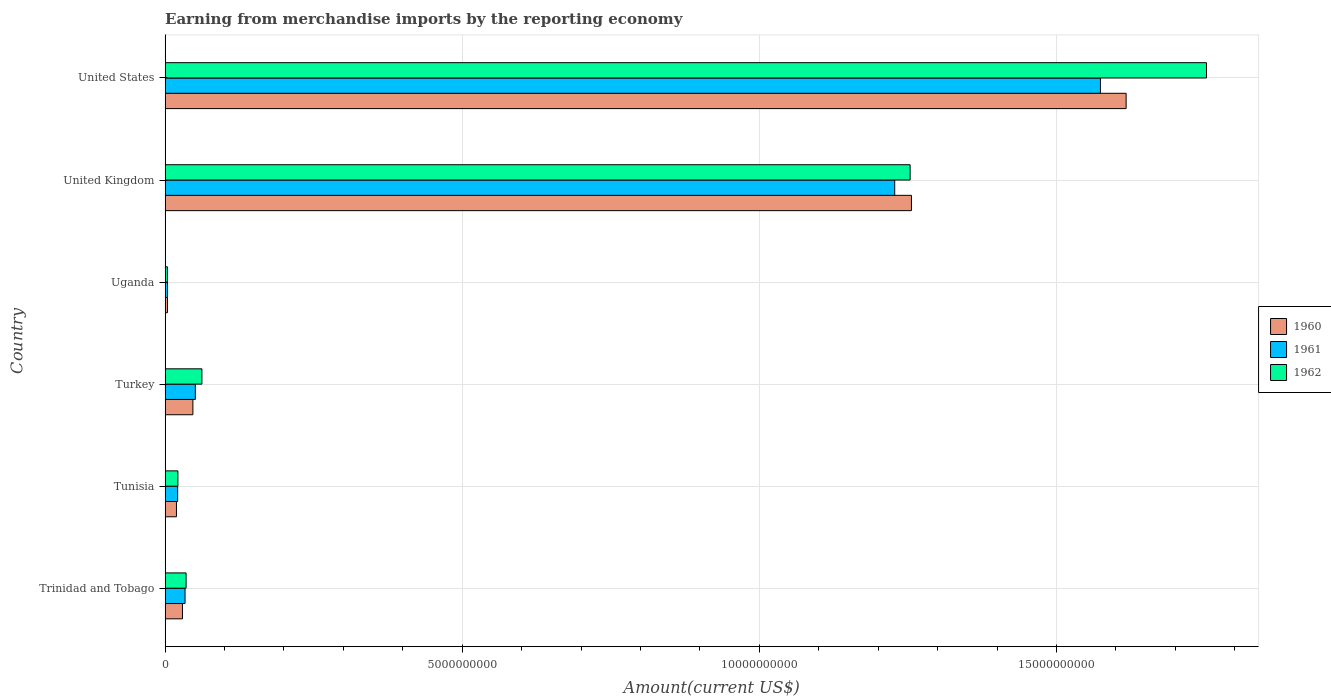Are the number of bars per tick equal to the number of legend labels?
Offer a very short reply. Yes. Are the number of bars on each tick of the Y-axis equal?
Ensure brevity in your answer.  Yes. How many bars are there on the 6th tick from the bottom?
Your answer should be very brief. 3. What is the label of the 2nd group of bars from the top?
Offer a terse response. United Kingdom. What is the amount earned from merchandise imports in 1960 in United Kingdom?
Provide a short and direct response. 1.26e+1. Across all countries, what is the maximum amount earned from merchandise imports in 1960?
Make the answer very short. 1.62e+1. Across all countries, what is the minimum amount earned from merchandise imports in 1960?
Your answer should be compact. 4.01e+07. In which country was the amount earned from merchandise imports in 1960 minimum?
Your answer should be very brief. Uganda. What is the total amount earned from merchandise imports in 1960 in the graph?
Your answer should be very brief. 2.97e+1. What is the difference between the amount earned from merchandise imports in 1960 in Tunisia and that in United States?
Provide a short and direct response. -1.60e+1. What is the difference between the amount earned from merchandise imports in 1960 in Uganda and the amount earned from merchandise imports in 1961 in United States?
Your answer should be very brief. -1.57e+1. What is the average amount earned from merchandise imports in 1961 per country?
Offer a terse response. 4.85e+09. What is the difference between the amount earned from merchandise imports in 1961 and amount earned from merchandise imports in 1960 in Turkey?
Make the answer very short. 4.11e+07. In how many countries, is the amount earned from merchandise imports in 1962 greater than 6000000000 US$?
Offer a terse response. 2. What is the ratio of the amount earned from merchandise imports in 1962 in Trinidad and Tobago to that in Turkey?
Offer a terse response. 0.57. Is the amount earned from merchandise imports in 1960 in Turkey less than that in Uganda?
Make the answer very short. No. Is the difference between the amount earned from merchandise imports in 1961 in Uganda and United States greater than the difference between the amount earned from merchandise imports in 1960 in Uganda and United States?
Ensure brevity in your answer.  Yes. What is the difference between the highest and the second highest amount earned from merchandise imports in 1962?
Give a very brief answer. 4.99e+09. What is the difference between the highest and the lowest amount earned from merchandise imports in 1962?
Ensure brevity in your answer.  1.75e+1. Is the sum of the amount earned from merchandise imports in 1961 in Trinidad and Tobago and United States greater than the maximum amount earned from merchandise imports in 1960 across all countries?
Your answer should be compact. No. What does the 1st bar from the bottom in United States represents?
Offer a terse response. 1960. Are all the bars in the graph horizontal?
Offer a terse response. Yes. How many countries are there in the graph?
Offer a terse response. 6. What is the difference between two consecutive major ticks on the X-axis?
Give a very brief answer. 5.00e+09. Does the graph contain any zero values?
Give a very brief answer. No. Does the graph contain grids?
Ensure brevity in your answer.  Yes. How many legend labels are there?
Keep it short and to the point. 3. How are the legend labels stacked?
Ensure brevity in your answer.  Vertical. What is the title of the graph?
Offer a very short reply. Earning from merchandise imports by the reporting economy. What is the label or title of the X-axis?
Ensure brevity in your answer.  Amount(current US$). What is the Amount(current US$) of 1960 in Trinidad and Tobago?
Your answer should be compact. 2.92e+08. What is the Amount(current US$) of 1961 in Trinidad and Tobago?
Offer a very short reply. 3.36e+08. What is the Amount(current US$) in 1962 in Trinidad and Tobago?
Ensure brevity in your answer.  3.53e+08. What is the Amount(current US$) in 1960 in Tunisia?
Give a very brief answer. 1.91e+08. What is the Amount(current US$) of 1961 in Tunisia?
Ensure brevity in your answer.  2.11e+08. What is the Amount(current US$) of 1962 in Tunisia?
Your answer should be very brief. 2.15e+08. What is the Amount(current US$) in 1960 in Turkey?
Offer a terse response. 4.68e+08. What is the Amount(current US$) of 1961 in Turkey?
Ensure brevity in your answer.  5.09e+08. What is the Amount(current US$) in 1962 in Turkey?
Offer a very short reply. 6.19e+08. What is the Amount(current US$) of 1960 in Uganda?
Provide a succinct answer. 4.01e+07. What is the Amount(current US$) of 1961 in Uganda?
Your response must be concise. 4.11e+07. What is the Amount(current US$) of 1962 in Uganda?
Provide a succinct answer. 3.90e+07. What is the Amount(current US$) in 1960 in United Kingdom?
Your answer should be very brief. 1.26e+1. What is the Amount(current US$) of 1961 in United Kingdom?
Offer a terse response. 1.23e+1. What is the Amount(current US$) of 1962 in United Kingdom?
Your answer should be compact. 1.25e+1. What is the Amount(current US$) in 1960 in United States?
Give a very brief answer. 1.62e+1. What is the Amount(current US$) of 1961 in United States?
Offer a terse response. 1.57e+1. What is the Amount(current US$) of 1962 in United States?
Offer a terse response. 1.75e+1. Across all countries, what is the maximum Amount(current US$) of 1960?
Offer a terse response. 1.62e+1. Across all countries, what is the maximum Amount(current US$) of 1961?
Your answer should be compact. 1.57e+1. Across all countries, what is the maximum Amount(current US$) in 1962?
Your response must be concise. 1.75e+1. Across all countries, what is the minimum Amount(current US$) in 1960?
Provide a succinct answer. 4.01e+07. Across all countries, what is the minimum Amount(current US$) of 1961?
Ensure brevity in your answer.  4.11e+07. Across all countries, what is the minimum Amount(current US$) of 1962?
Your response must be concise. 3.90e+07. What is the total Amount(current US$) of 1960 in the graph?
Your answer should be compact. 2.97e+1. What is the total Amount(current US$) in 1961 in the graph?
Keep it short and to the point. 2.91e+1. What is the total Amount(current US$) of 1962 in the graph?
Give a very brief answer. 3.13e+1. What is the difference between the Amount(current US$) of 1960 in Trinidad and Tobago and that in Tunisia?
Offer a terse response. 1.01e+08. What is the difference between the Amount(current US$) of 1961 in Trinidad and Tobago and that in Tunisia?
Provide a short and direct response. 1.24e+08. What is the difference between the Amount(current US$) in 1962 in Trinidad and Tobago and that in Tunisia?
Your answer should be very brief. 1.38e+08. What is the difference between the Amount(current US$) in 1960 in Trinidad and Tobago and that in Turkey?
Offer a very short reply. -1.75e+08. What is the difference between the Amount(current US$) in 1961 in Trinidad and Tobago and that in Turkey?
Provide a short and direct response. -1.73e+08. What is the difference between the Amount(current US$) in 1962 in Trinidad and Tobago and that in Turkey?
Provide a succinct answer. -2.66e+08. What is the difference between the Amount(current US$) of 1960 in Trinidad and Tobago and that in Uganda?
Offer a terse response. 2.52e+08. What is the difference between the Amount(current US$) of 1961 in Trinidad and Tobago and that in Uganda?
Your answer should be compact. 2.95e+08. What is the difference between the Amount(current US$) of 1962 in Trinidad and Tobago and that in Uganda?
Ensure brevity in your answer.  3.14e+08. What is the difference between the Amount(current US$) of 1960 in Trinidad and Tobago and that in United Kingdom?
Offer a terse response. -1.23e+1. What is the difference between the Amount(current US$) of 1961 in Trinidad and Tobago and that in United Kingdom?
Your answer should be compact. -1.19e+1. What is the difference between the Amount(current US$) of 1962 in Trinidad and Tobago and that in United Kingdom?
Your answer should be very brief. -1.22e+1. What is the difference between the Amount(current US$) in 1960 in Trinidad and Tobago and that in United States?
Offer a very short reply. -1.59e+1. What is the difference between the Amount(current US$) of 1961 in Trinidad and Tobago and that in United States?
Your answer should be very brief. -1.54e+1. What is the difference between the Amount(current US$) in 1962 in Trinidad and Tobago and that in United States?
Offer a terse response. -1.72e+1. What is the difference between the Amount(current US$) in 1960 in Tunisia and that in Turkey?
Ensure brevity in your answer.  -2.77e+08. What is the difference between the Amount(current US$) of 1961 in Tunisia and that in Turkey?
Provide a short and direct response. -2.97e+08. What is the difference between the Amount(current US$) in 1962 in Tunisia and that in Turkey?
Your answer should be very brief. -4.04e+08. What is the difference between the Amount(current US$) in 1960 in Tunisia and that in Uganda?
Keep it short and to the point. 1.51e+08. What is the difference between the Amount(current US$) of 1961 in Tunisia and that in Uganda?
Your response must be concise. 1.70e+08. What is the difference between the Amount(current US$) in 1962 in Tunisia and that in Uganda?
Your answer should be very brief. 1.76e+08. What is the difference between the Amount(current US$) in 1960 in Tunisia and that in United Kingdom?
Give a very brief answer. -1.24e+1. What is the difference between the Amount(current US$) of 1961 in Tunisia and that in United Kingdom?
Give a very brief answer. -1.21e+1. What is the difference between the Amount(current US$) in 1962 in Tunisia and that in United Kingdom?
Provide a short and direct response. -1.23e+1. What is the difference between the Amount(current US$) of 1960 in Tunisia and that in United States?
Provide a succinct answer. -1.60e+1. What is the difference between the Amount(current US$) of 1961 in Tunisia and that in United States?
Give a very brief answer. -1.55e+1. What is the difference between the Amount(current US$) of 1962 in Tunisia and that in United States?
Provide a short and direct response. -1.73e+1. What is the difference between the Amount(current US$) in 1960 in Turkey and that in Uganda?
Keep it short and to the point. 4.28e+08. What is the difference between the Amount(current US$) of 1961 in Turkey and that in Uganda?
Your answer should be very brief. 4.68e+08. What is the difference between the Amount(current US$) of 1962 in Turkey and that in Uganda?
Your answer should be very brief. 5.80e+08. What is the difference between the Amount(current US$) in 1960 in Turkey and that in United Kingdom?
Ensure brevity in your answer.  -1.21e+1. What is the difference between the Amount(current US$) in 1961 in Turkey and that in United Kingdom?
Offer a very short reply. -1.18e+1. What is the difference between the Amount(current US$) of 1962 in Turkey and that in United Kingdom?
Your response must be concise. -1.19e+1. What is the difference between the Amount(current US$) of 1960 in Turkey and that in United States?
Your response must be concise. -1.57e+1. What is the difference between the Amount(current US$) in 1961 in Turkey and that in United States?
Keep it short and to the point. -1.52e+1. What is the difference between the Amount(current US$) in 1962 in Turkey and that in United States?
Give a very brief answer. -1.69e+1. What is the difference between the Amount(current US$) of 1960 in Uganda and that in United Kingdom?
Make the answer very short. -1.25e+1. What is the difference between the Amount(current US$) in 1961 in Uganda and that in United Kingdom?
Your response must be concise. -1.22e+1. What is the difference between the Amount(current US$) of 1962 in Uganda and that in United Kingdom?
Ensure brevity in your answer.  -1.25e+1. What is the difference between the Amount(current US$) of 1960 in Uganda and that in United States?
Make the answer very short. -1.61e+1. What is the difference between the Amount(current US$) of 1961 in Uganda and that in United States?
Provide a succinct answer. -1.57e+1. What is the difference between the Amount(current US$) in 1962 in Uganda and that in United States?
Offer a very short reply. -1.75e+1. What is the difference between the Amount(current US$) of 1960 in United Kingdom and that in United States?
Provide a succinct answer. -3.61e+09. What is the difference between the Amount(current US$) of 1961 in United Kingdom and that in United States?
Keep it short and to the point. -3.46e+09. What is the difference between the Amount(current US$) of 1962 in United Kingdom and that in United States?
Ensure brevity in your answer.  -4.99e+09. What is the difference between the Amount(current US$) of 1960 in Trinidad and Tobago and the Amount(current US$) of 1961 in Tunisia?
Your answer should be very brief. 8.10e+07. What is the difference between the Amount(current US$) of 1960 in Trinidad and Tobago and the Amount(current US$) of 1962 in Tunisia?
Give a very brief answer. 7.72e+07. What is the difference between the Amount(current US$) in 1961 in Trinidad and Tobago and the Amount(current US$) in 1962 in Tunisia?
Your answer should be very brief. 1.20e+08. What is the difference between the Amount(current US$) of 1960 in Trinidad and Tobago and the Amount(current US$) of 1961 in Turkey?
Keep it short and to the point. -2.16e+08. What is the difference between the Amount(current US$) of 1960 in Trinidad and Tobago and the Amount(current US$) of 1962 in Turkey?
Your answer should be very brief. -3.27e+08. What is the difference between the Amount(current US$) in 1961 in Trinidad and Tobago and the Amount(current US$) in 1962 in Turkey?
Ensure brevity in your answer.  -2.84e+08. What is the difference between the Amount(current US$) in 1960 in Trinidad and Tobago and the Amount(current US$) in 1961 in Uganda?
Your answer should be very brief. 2.51e+08. What is the difference between the Amount(current US$) in 1960 in Trinidad and Tobago and the Amount(current US$) in 1962 in Uganda?
Your answer should be very brief. 2.53e+08. What is the difference between the Amount(current US$) of 1961 in Trinidad and Tobago and the Amount(current US$) of 1962 in Uganda?
Give a very brief answer. 2.97e+08. What is the difference between the Amount(current US$) of 1960 in Trinidad and Tobago and the Amount(current US$) of 1961 in United Kingdom?
Give a very brief answer. -1.20e+1. What is the difference between the Amount(current US$) in 1960 in Trinidad and Tobago and the Amount(current US$) in 1962 in United Kingdom?
Your answer should be compact. -1.22e+1. What is the difference between the Amount(current US$) in 1961 in Trinidad and Tobago and the Amount(current US$) in 1962 in United Kingdom?
Offer a very short reply. -1.22e+1. What is the difference between the Amount(current US$) in 1960 in Trinidad and Tobago and the Amount(current US$) in 1961 in United States?
Your response must be concise. -1.54e+1. What is the difference between the Amount(current US$) of 1960 in Trinidad and Tobago and the Amount(current US$) of 1962 in United States?
Provide a succinct answer. -1.72e+1. What is the difference between the Amount(current US$) of 1961 in Trinidad and Tobago and the Amount(current US$) of 1962 in United States?
Provide a succinct answer. -1.72e+1. What is the difference between the Amount(current US$) in 1960 in Tunisia and the Amount(current US$) in 1961 in Turkey?
Offer a very short reply. -3.18e+08. What is the difference between the Amount(current US$) in 1960 in Tunisia and the Amount(current US$) in 1962 in Turkey?
Make the answer very short. -4.28e+08. What is the difference between the Amount(current US$) of 1961 in Tunisia and the Amount(current US$) of 1962 in Turkey?
Offer a very short reply. -4.08e+08. What is the difference between the Amount(current US$) in 1960 in Tunisia and the Amount(current US$) in 1961 in Uganda?
Provide a succinct answer. 1.50e+08. What is the difference between the Amount(current US$) in 1960 in Tunisia and the Amount(current US$) in 1962 in Uganda?
Offer a terse response. 1.52e+08. What is the difference between the Amount(current US$) in 1961 in Tunisia and the Amount(current US$) in 1962 in Uganda?
Offer a very short reply. 1.72e+08. What is the difference between the Amount(current US$) in 1960 in Tunisia and the Amount(current US$) in 1961 in United Kingdom?
Your answer should be very brief. -1.21e+1. What is the difference between the Amount(current US$) in 1960 in Tunisia and the Amount(current US$) in 1962 in United Kingdom?
Provide a short and direct response. -1.23e+1. What is the difference between the Amount(current US$) of 1961 in Tunisia and the Amount(current US$) of 1962 in United Kingdom?
Make the answer very short. -1.23e+1. What is the difference between the Amount(current US$) in 1960 in Tunisia and the Amount(current US$) in 1961 in United States?
Offer a very short reply. -1.55e+1. What is the difference between the Amount(current US$) in 1960 in Tunisia and the Amount(current US$) in 1962 in United States?
Give a very brief answer. -1.73e+1. What is the difference between the Amount(current US$) of 1961 in Tunisia and the Amount(current US$) of 1962 in United States?
Make the answer very short. -1.73e+1. What is the difference between the Amount(current US$) in 1960 in Turkey and the Amount(current US$) in 1961 in Uganda?
Your answer should be compact. 4.27e+08. What is the difference between the Amount(current US$) of 1960 in Turkey and the Amount(current US$) of 1962 in Uganda?
Keep it short and to the point. 4.29e+08. What is the difference between the Amount(current US$) of 1961 in Turkey and the Amount(current US$) of 1962 in Uganda?
Offer a terse response. 4.70e+08. What is the difference between the Amount(current US$) of 1960 in Turkey and the Amount(current US$) of 1961 in United Kingdom?
Offer a terse response. -1.18e+1. What is the difference between the Amount(current US$) in 1960 in Turkey and the Amount(current US$) in 1962 in United Kingdom?
Provide a short and direct response. -1.21e+1. What is the difference between the Amount(current US$) in 1961 in Turkey and the Amount(current US$) in 1962 in United Kingdom?
Your answer should be very brief. -1.20e+1. What is the difference between the Amount(current US$) of 1960 in Turkey and the Amount(current US$) of 1961 in United States?
Give a very brief answer. -1.53e+1. What is the difference between the Amount(current US$) in 1960 in Turkey and the Amount(current US$) in 1962 in United States?
Provide a short and direct response. -1.71e+1. What is the difference between the Amount(current US$) of 1961 in Turkey and the Amount(current US$) of 1962 in United States?
Provide a short and direct response. -1.70e+1. What is the difference between the Amount(current US$) of 1960 in Uganda and the Amount(current US$) of 1961 in United Kingdom?
Your response must be concise. -1.22e+1. What is the difference between the Amount(current US$) in 1960 in Uganda and the Amount(current US$) in 1962 in United Kingdom?
Provide a succinct answer. -1.25e+1. What is the difference between the Amount(current US$) in 1961 in Uganda and the Amount(current US$) in 1962 in United Kingdom?
Offer a terse response. -1.25e+1. What is the difference between the Amount(current US$) of 1960 in Uganda and the Amount(current US$) of 1961 in United States?
Ensure brevity in your answer.  -1.57e+1. What is the difference between the Amount(current US$) of 1960 in Uganda and the Amount(current US$) of 1962 in United States?
Your answer should be very brief. -1.75e+1. What is the difference between the Amount(current US$) in 1961 in Uganda and the Amount(current US$) in 1962 in United States?
Offer a terse response. -1.75e+1. What is the difference between the Amount(current US$) of 1960 in United Kingdom and the Amount(current US$) of 1961 in United States?
Provide a succinct answer. -3.18e+09. What is the difference between the Amount(current US$) of 1960 in United Kingdom and the Amount(current US$) of 1962 in United States?
Keep it short and to the point. -4.96e+09. What is the difference between the Amount(current US$) in 1961 in United Kingdom and the Amount(current US$) in 1962 in United States?
Your answer should be compact. -5.25e+09. What is the average Amount(current US$) of 1960 per country?
Your response must be concise. 4.95e+09. What is the average Amount(current US$) of 1961 per country?
Provide a succinct answer. 4.85e+09. What is the average Amount(current US$) of 1962 per country?
Provide a short and direct response. 5.21e+09. What is the difference between the Amount(current US$) of 1960 and Amount(current US$) of 1961 in Trinidad and Tobago?
Provide a succinct answer. -4.33e+07. What is the difference between the Amount(current US$) in 1960 and Amount(current US$) in 1962 in Trinidad and Tobago?
Keep it short and to the point. -6.08e+07. What is the difference between the Amount(current US$) in 1961 and Amount(current US$) in 1962 in Trinidad and Tobago?
Your answer should be very brief. -1.75e+07. What is the difference between the Amount(current US$) in 1960 and Amount(current US$) in 1961 in Tunisia?
Offer a terse response. -2.03e+07. What is the difference between the Amount(current US$) of 1960 and Amount(current US$) of 1962 in Tunisia?
Provide a succinct answer. -2.41e+07. What is the difference between the Amount(current US$) of 1961 and Amount(current US$) of 1962 in Tunisia?
Provide a succinct answer. -3.80e+06. What is the difference between the Amount(current US$) of 1960 and Amount(current US$) of 1961 in Turkey?
Provide a short and direct response. -4.11e+07. What is the difference between the Amount(current US$) in 1960 and Amount(current US$) in 1962 in Turkey?
Ensure brevity in your answer.  -1.52e+08. What is the difference between the Amount(current US$) of 1961 and Amount(current US$) of 1962 in Turkey?
Provide a short and direct response. -1.10e+08. What is the difference between the Amount(current US$) in 1960 and Amount(current US$) in 1961 in Uganda?
Offer a very short reply. -1.00e+06. What is the difference between the Amount(current US$) of 1960 and Amount(current US$) of 1962 in Uganda?
Give a very brief answer. 1.10e+06. What is the difference between the Amount(current US$) of 1961 and Amount(current US$) of 1962 in Uganda?
Offer a terse response. 2.10e+06. What is the difference between the Amount(current US$) of 1960 and Amount(current US$) of 1961 in United Kingdom?
Offer a very short reply. 2.82e+08. What is the difference between the Amount(current US$) in 1960 and Amount(current US$) in 1962 in United Kingdom?
Give a very brief answer. 2.22e+07. What is the difference between the Amount(current US$) in 1961 and Amount(current US$) in 1962 in United Kingdom?
Provide a succinct answer. -2.59e+08. What is the difference between the Amount(current US$) of 1960 and Amount(current US$) of 1961 in United States?
Your answer should be compact. 4.32e+08. What is the difference between the Amount(current US$) in 1960 and Amount(current US$) in 1962 in United States?
Your answer should be compact. -1.35e+09. What is the difference between the Amount(current US$) of 1961 and Amount(current US$) of 1962 in United States?
Give a very brief answer. -1.78e+09. What is the ratio of the Amount(current US$) of 1960 in Trinidad and Tobago to that in Tunisia?
Your answer should be very brief. 1.53. What is the ratio of the Amount(current US$) of 1961 in Trinidad and Tobago to that in Tunisia?
Offer a very short reply. 1.59. What is the ratio of the Amount(current US$) of 1962 in Trinidad and Tobago to that in Tunisia?
Make the answer very short. 1.64. What is the ratio of the Amount(current US$) of 1960 in Trinidad and Tobago to that in Turkey?
Offer a very short reply. 0.63. What is the ratio of the Amount(current US$) in 1961 in Trinidad and Tobago to that in Turkey?
Provide a succinct answer. 0.66. What is the ratio of the Amount(current US$) of 1962 in Trinidad and Tobago to that in Turkey?
Keep it short and to the point. 0.57. What is the ratio of the Amount(current US$) in 1960 in Trinidad and Tobago to that in Uganda?
Give a very brief answer. 7.29. What is the ratio of the Amount(current US$) of 1961 in Trinidad and Tobago to that in Uganda?
Offer a terse response. 8.17. What is the ratio of the Amount(current US$) of 1962 in Trinidad and Tobago to that in Uganda?
Your answer should be compact. 9.06. What is the ratio of the Amount(current US$) of 1960 in Trinidad and Tobago to that in United Kingdom?
Your answer should be very brief. 0.02. What is the ratio of the Amount(current US$) of 1961 in Trinidad and Tobago to that in United Kingdom?
Make the answer very short. 0.03. What is the ratio of the Amount(current US$) in 1962 in Trinidad and Tobago to that in United Kingdom?
Ensure brevity in your answer.  0.03. What is the ratio of the Amount(current US$) in 1960 in Trinidad and Tobago to that in United States?
Make the answer very short. 0.02. What is the ratio of the Amount(current US$) in 1961 in Trinidad and Tobago to that in United States?
Provide a succinct answer. 0.02. What is the ratio of the Amount(current US$) of 1962 in Trinidad and Tobago to that in United States?
Your response must be concise. 0.02. What is the ratio of the Amount(current US$) in 1960 in Tunisia to that in Turkey?
Offer a very short reply. 0.41. What is the ratio of the Amount(current US$) of 1961 in Tunisia to that in Turkey?
Offer a terse response. 0.42. What is the ratio of the Amount(current US$) of 1962 in Tunisia to that in Turkey?
Keep it short and to the point. 0.35. What is the ratio of the Amount(current US$) in 1960 in Tunisia to that in Uganda?
Keep it short and to the point. 4.77. What is the ratio of the Amount(current US$) in 1961 in Tunisia to that in Uganda?
Offer a very short reply. 5.14. What is the ratio of the Amount(current US$) of 1962 in Tunisia to that in Uganda?
Offer a very short reply. 5.52. What is the ratio of the Amount(current US$) of 1960 in Tunisia to that in United Kingdom?
Keep it short and to the point. 0.02. What is the ratio of the Amount(current US$) of 1961 in Tunisia to that in United Kingdom?
Provide a succinct answer. 0.02. What is the ratio of the Amount(current US$) of 1962 in Tunisia to that in United Kingdom?
Keep it short and to the point. 0.02. What is the ratio of the Amount(current US$) in 1960 in Tunisia to that in United States?
Your answer should be compact. 0.01. What is the ratio of the Amount(current US$) of 1961 in Tunisia to that in United States?
Offer a terse response. 0.01. What is the ratio of the Amount(current US$) in 1962 in Tunisia to that in United States?
Your answer should be compact. 0.01. What is the ratio of the Amount(current US$) of 1960 in Turkey to that in Uganda?
Your answer should be compact. 11.66. What is the ratio of the Amount(current US$) of 1961 in Turkey to that in Uganda?
Keep it short and to the point. 12.38. What is the ratio of the Amount(current US$) of 1962 in Turkey to that in Uganda?
Ensure brevity in your answer.  15.88. What is the ratio of the Amount(current US$) in 1960 in Turkey to that in United Kingdom?
Offer a terse response. 0.04. What is the ratio of the Amount(current US$) of 1961 in Turkey to that in United Kingdom?
Provide a succinct answer. 0.04. What is the ratio of the Amount(current US$) in 1962 in Turkey to that in United Kingdom?
Ensure brevity in your answer.  0.05. What is the ratio of the Amount(current US$) in 1960 in Turkey to that in United States?
Provide a succinct answer. 0.03. What is the ratio of the Amount(current US$) in 1961 in Turkey to that in United States?
Make the answer very short. 0.03. What is the ratio of the Amount(current US$) in 1962 in Turkey to that in United States?
Give a very brief answer. 0.04. What is the ratio of the Amount(current US$) in 1960 in Uganda to that in United Kingdom?
Your answer should be very brief. 0. What is the ratio of the Amount(current US$) of 1961 in Uganda to that in United Kingdom?
Offer a very short reply. 0. What is the ratio of the Amount(current US$) of 1962 in Uganda to that in United Kingdom?
Give a very brief answer. 0. What is the ratio of the Amount(current US$) in 1960 in Uganda to that in United States?
Give a very brief answer. 0. What is the ratio of the Amount(current US$) in 1961 in Uganda to that in United States?
Offer a very short reply. 0. What is the ratio of the Amount(current US$) in 1962 in Uganda to that in United States?
Your response must be concise. 0. What is the ratio of the Amount(current US$) of 1960 in United Kingdom to that in United States?
Provide a succinct answer. 0.78. What is the ratio of the Amount(current US$) in 1961 in United Kingdom to that in United States?
Your response must be concise. 0.78. What is the ratio of the Amount(current US$) in 1962 in United Kingdom to that in United States?
Your answer should be very brief. 0.72. What is the difference between the highest and the second highest Amount(current US$) of 1960?
Ensure brevity in your answer.  3.61e+09. What is the difference between the highest and the second highest Amount(current US$) of 1961?
Offer a terse response. 3.46e+09. What is the difference between the highest and the second highest Amount(current US$) in 1962?
Your answer should be compact. 4.99e+09. What is the difference between the highest and the lowest Amount(current US$) in 1960?
Keep it short and to the point. 1.61e+1. What is the difference between the highest and the lowest Amount(current US$) in 1961?
Keep it short and to the point. 1.57e+1. What is the difference between the highest and the lowest Amount(current US$) in 1962?
Keep it short and to the point. 1.75e+1. 